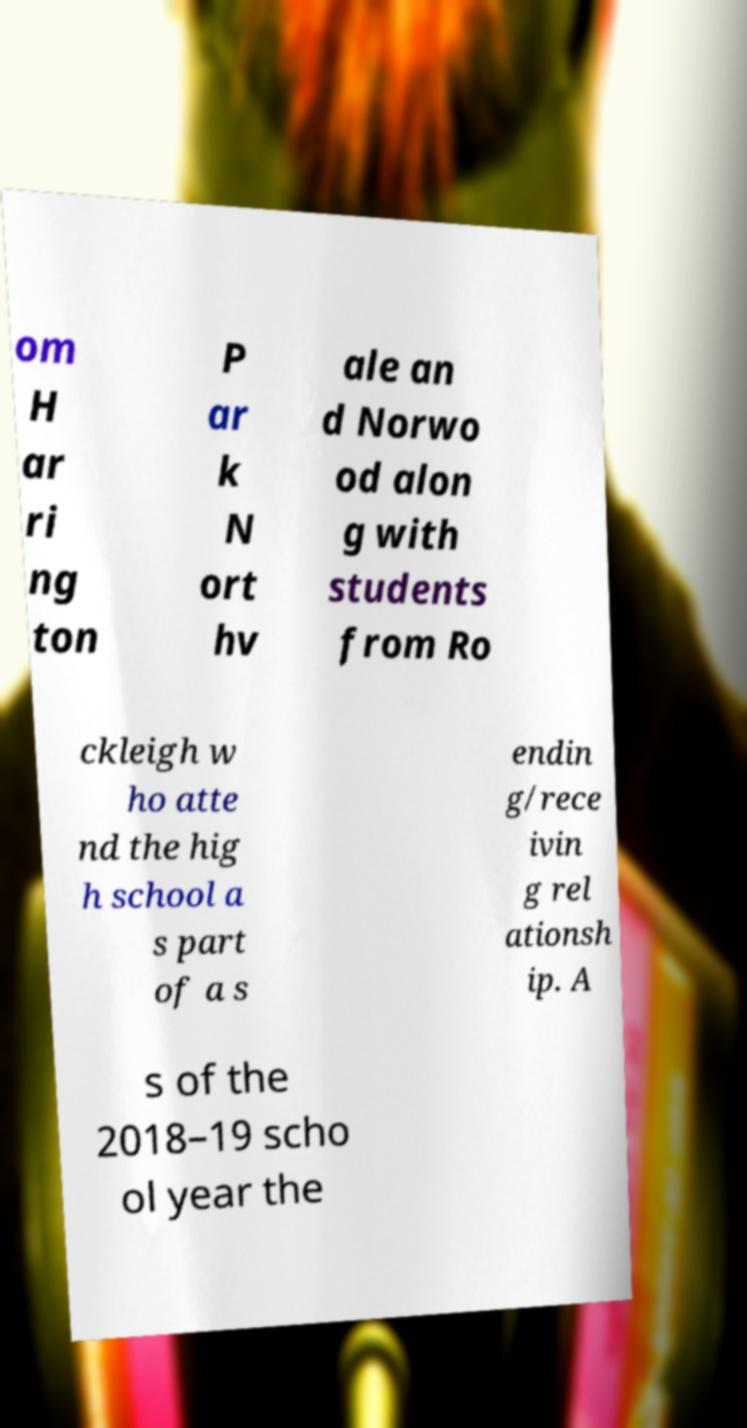I need the written content from this picture converted into text. Can you do that? om H ar ri ng ton P ar k N ort hv ale an d Norwo od alon g with students from Ro ckleigh w ho atte nd the hig h school a s part of a s endin g/rece ivin g rel ationsh ip. A s of the 2018–19 scho ol year the 